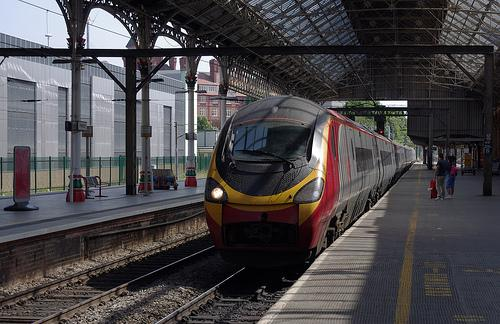Question: why was this photo taken?
Choices:
A. For a newspaper.
B. For a yearbook.
C. For a blog.
D. For a journal.
Answer with the letter. Answer: A Question: when is this a photo of?
Choices:
A. A car.
B. A train.
C. A bus.
D. A subway car.
Answer with the letter. Answer: B Question: how many trains are there?
Choices:
A. One.
B. Two.
C. Three.
D. Four.
Answer with the letter. Answer: A 